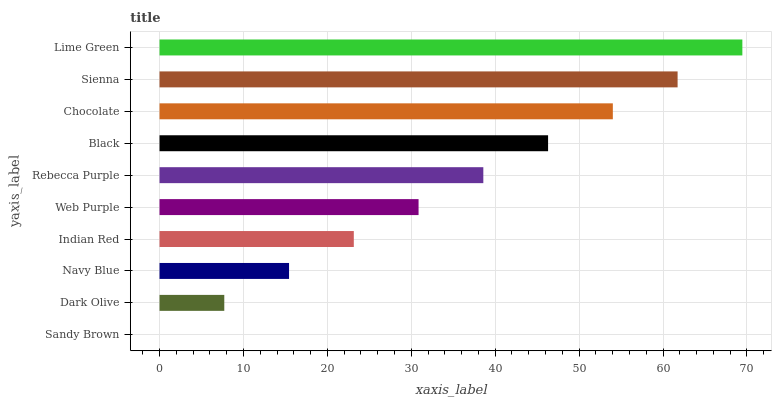Is Sandy Brown the minimum?
Answer yes or no. Yes. Is Lime Green the maximum?
Answer yes or no. Yes. Is Dark Olive the minimum?
Answer yes or no. No. Is Dark Olive the maximum?
Answer yes or no. No. Is Dark Olive greater than Sandy Brown?
Answer yes or no. Yes. Is Sandy Brown less than Dark Olive?
Answer yes or no. Yes. Is Sandy Brown greater than Dark Olive?
Answer yes or no. No. Is Dark Olive less than Sandy Brown?
Answer yes or no. No. Is Rebecca Purple the high median?
Answer yes or no. Yes. Is Web Purple the low median?
Answer yes or no. Yes. Is Dark Olive the high median?
Answer yes or no. No. Is Navy Blue the low median?
Answer yes or no. No. 